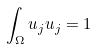Convert formula to latex. <formula><loc_0><loc_0><loc_500><loc_500>\int _ { \Omega } u _ { j } u _ { j } = 1</formula> 